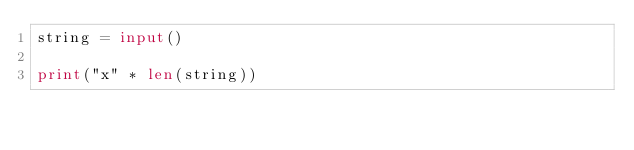Convert code to text. <code><loc_0><loc_0><loc_500><loc_500><_Python_>string = input()

print("x" * len(string))</code> 